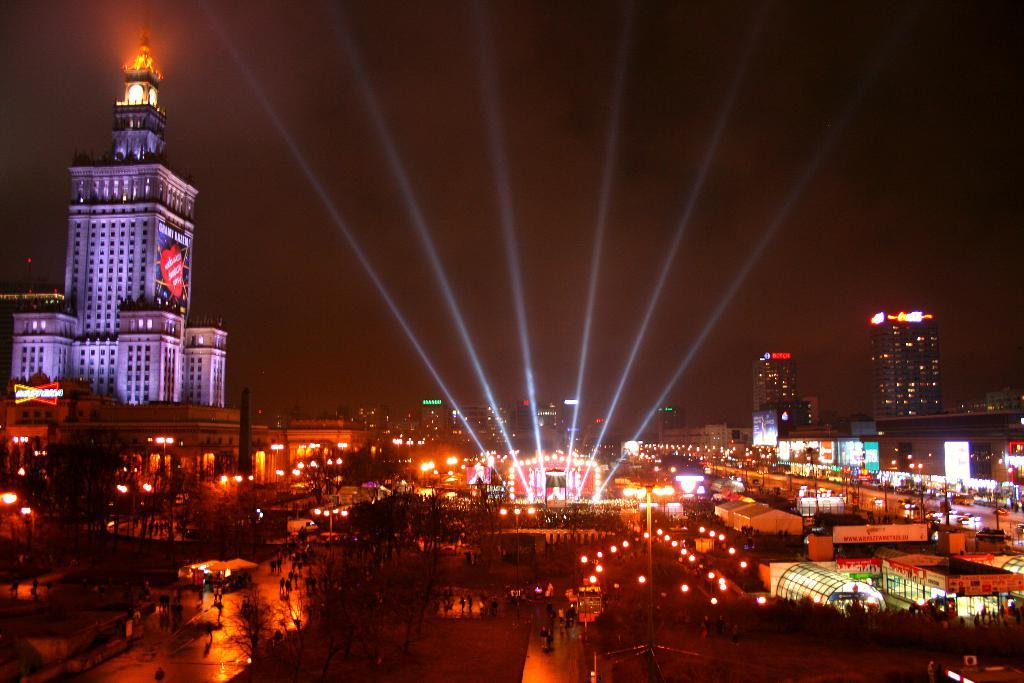Where was the image taken? The image was clicked outside. What can be seen in the foreground of the image? There is a group of people in the foreground. What type of artificial light sources can be seen in the image? There are lights visible in the image. What type of structures are present in the image? There are buildings and skyscrapers visible in the image. What type of natural elements are present in the image? Trees are present in the image. What part of the natural environment is visible in the image? The sky is visible in the image. What type of tin can be seen in the image? There is no tin present in the image. What type of sand can be seen in the image? There is no sand present in the image. 